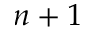Convert formula to latex. <formula><loc_0><loc_0><loc_500><loc_500>n + 1</formula> 